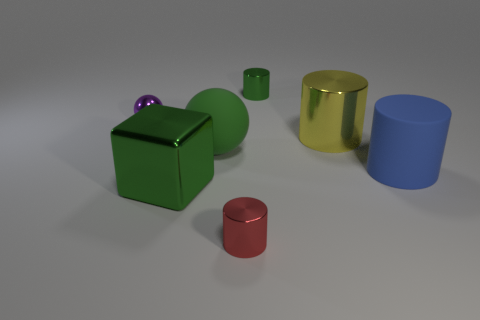Can you describe the texture of the objects in the image? Certainly! The objects in the image seem to have a smooth texture with a matte-like finish, likely characteristic of rubber or plastic materials. 